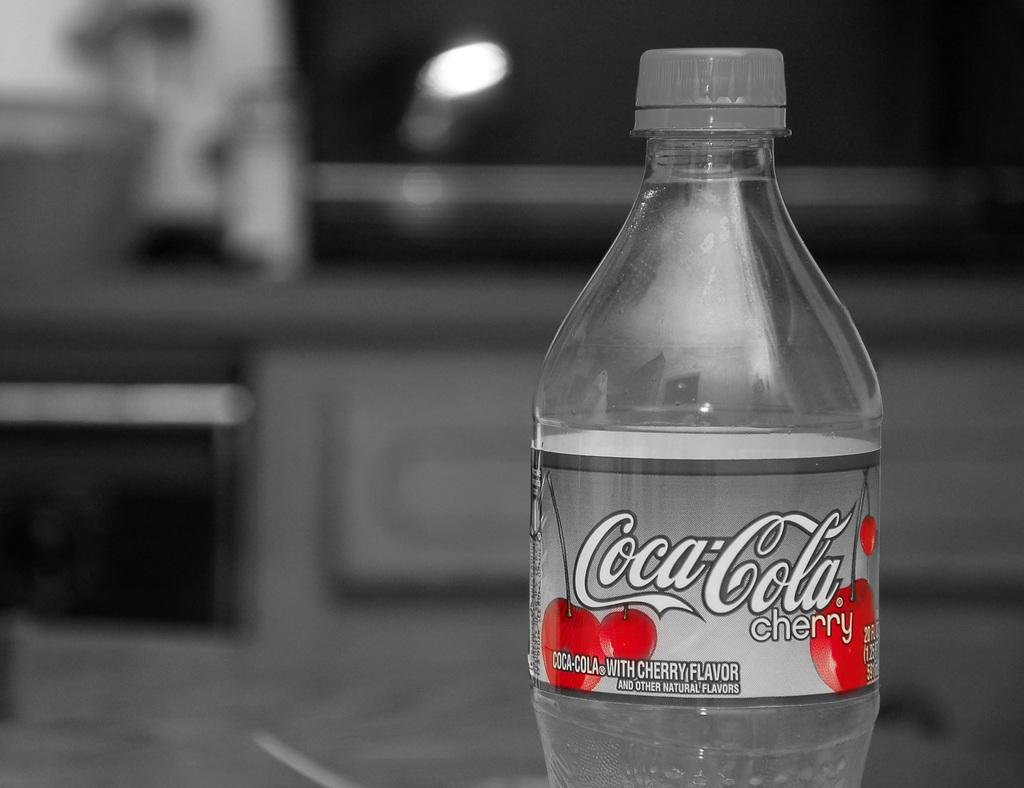What is present in the image? There is a bottle in the image. What is written on the bottle? The bottle has the words "Coca Cola Cherry" written on it. What color is the background behind the bottle? The background behind the bottle is blue. Are there any worms crawling on the bottle in the image? No, there are no worms present in the image. 